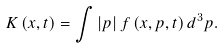Convert formula to latex. <formula><loc_0><loc_0><loc_500><loc_500>K \left ( x , t \right ) = \int \left | p \right | f \left ( x , p , t \right ) d ^ { 3 } p .</formula> 